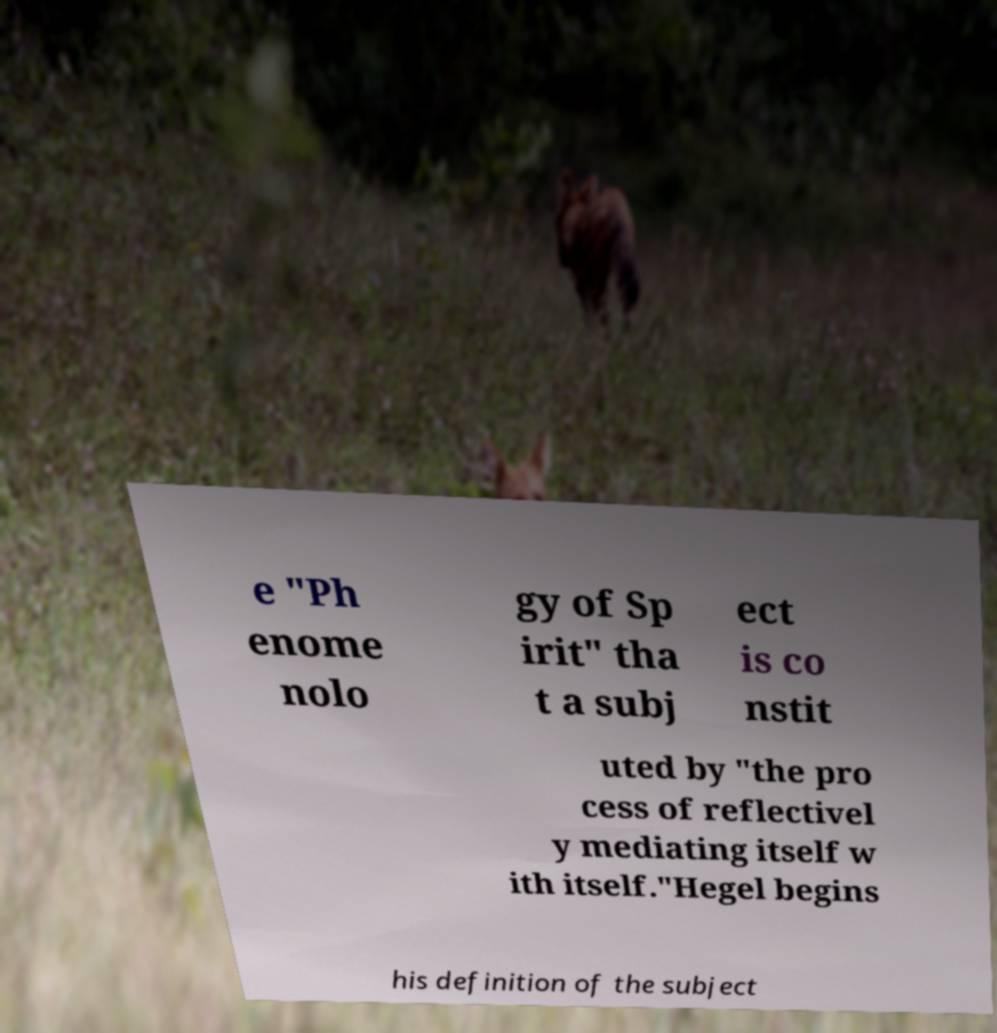Can you accurately transcribe the text from the provided image for me? e "Ph enome nolo gy of Sp irit" tha t a subj ect is co nstit uted by "the pro cess of reflectivel y mediating itself w ith itself."Hegel begins his definition of the subject 